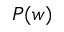Convert formula to latex. <formula><loc_0><loc_0><loc_500><loc_500>P ( w )</formula> 